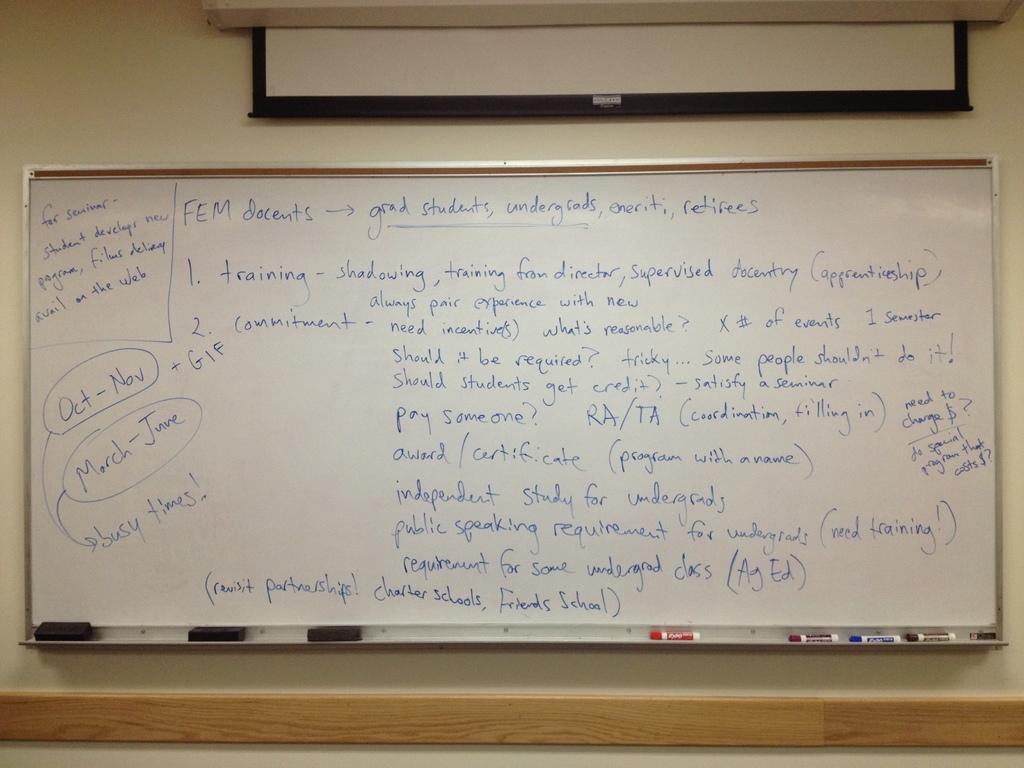Provide a one-sentence caption for the provided image. A side note on the whiteboard states Oct through Nov and March through June will be busy times. 